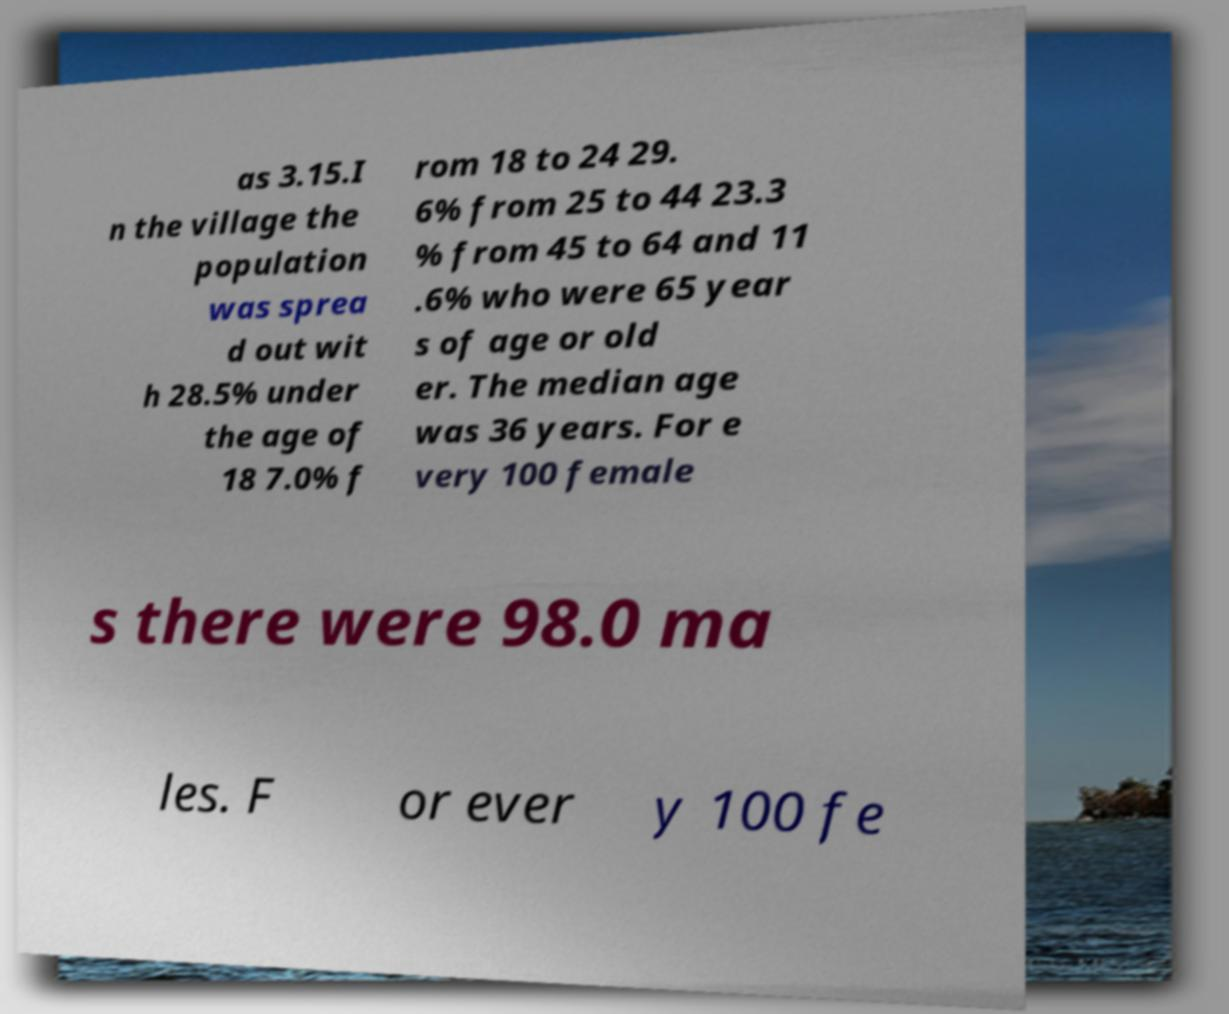Could you extract and type out the text from this image? as 3.15.I n the village the population was sprea d out wit h 28.5% under the age of 18 7.0% f rom 18 to 24 29. 6% from 25 to 44 23.3 % from 45 to 64 and 11 .6% who were 65 year s of age or old er. The median age was 36 years. For e very 100 female s there were 98.0 ma les. F or ever y 100 fe 